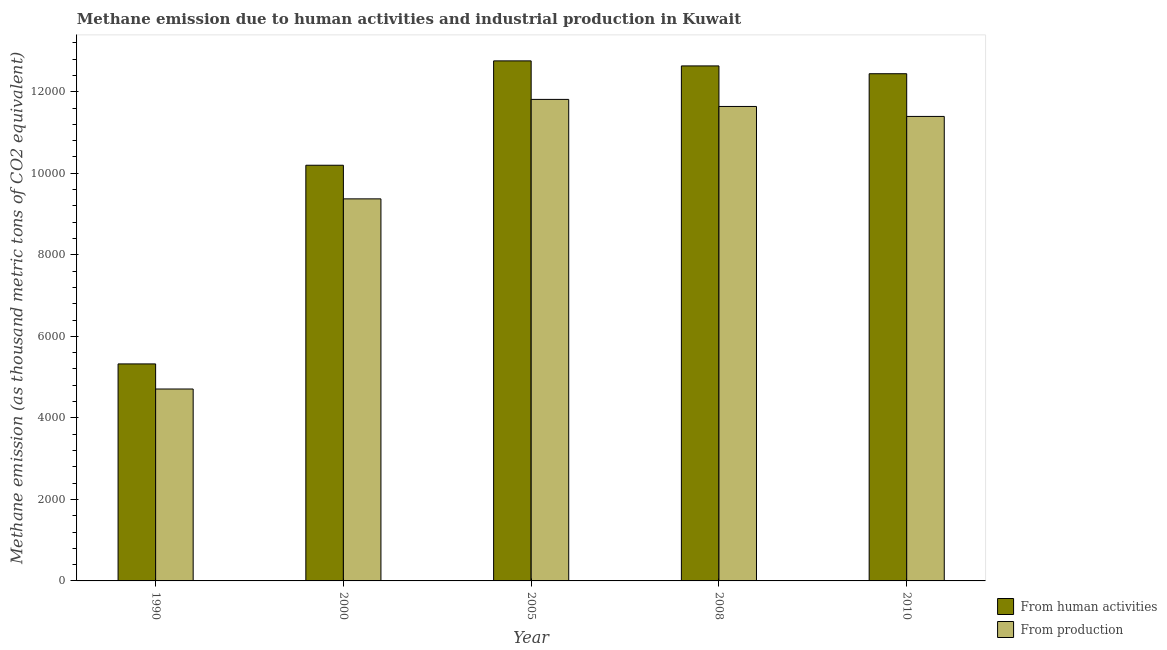How many different coloured bars are there?
Your answer should be very brief. 2. How many groups of bars are there?
Give a very brief answer. 5. Are the number of bars per tick equal to the number of legend labels?
Offer a terse response. Yes. How many bars are there on the 3rd tick from the left?
Provide a short and direct response. 2. What is the amount of emissions generated from industries in 2000?
Offer a very short reply. 9372. Across all years, what is the maximum amount of emissions from human activities?
Offer a terse response. 1.28e+04. Across all years, what is the minimum amount of emissions generated from industries?
Your answer should be compact. 4707.5. What is the total amount of emissions from human activities in the graph?
Make the answer very short. 5.34e+04. What is the difference between the amount of emissions from human activities in 2008 and that in 2010?
Your answer should be very brief. 191.4. What is the difference between the amount of emissions from human activities in 2005 and the amount of emissions generated from industries in 2010?
Make the answer very short. 315.1. What is the average amount of emissions generated from industries per year?
Ensure brevity in your answer.  9784.84. In the year 2005, what is the difference between the amount of emissions generated from industries and amount of emissions from human activities?
Provide a succinct answer. 0. In how many years, is the amount of emissions generated from industries greater than 4800 thousand metric tons?
Your response must be concise. 4. What is the ratio of the amount of emissions from human activities in 2000 to that in 2008?
Offer a very short reply. 0.81. Is the amount of emissions from human activities in 2000 less than that in 2005?
Provide a succinct answer. Yes. What is the difference between the highest and the second highest amount of emissions generated from industries?
Provide a short and direct response. 172.9. What is the difference between the highest and the lowest amount of emissions from human activities?
Make the answer very short. 7433.7. Is the sum of the amount of emissions from human activities in 2005 and 2008 greater than the maximum amount of emissions generated from industries across all years?
Give a very brief answer. Yes. What does the 2nd bar from the left in 1990 represents?
Ensure brevity in your answer.  From production. What does the 1st bar from the right in 2000 represents?
Provide a short and direct response. From production. How many bars are there?
Keep it short and to the point. 10. Are all the bars in the graph horizontal?
Make the answer very short. No. Does the graph contain any zero values?
Give a very brief answer. No. What is the title of the graph?
Your answer should be compact. Methane emission due to human activities and industrial production in Kuwait. Does "Taxes on profits and capital gains" appear as one of the legend labels in the graph?
Your answer should be very brief. No. What is the label or title of the Y-axis?
Keep it short and to the point. Methane emission (as thousand metric tons of CO2 equivalent). What is the Methane emission (as thousand metric tons of CO2 equivalent) of From human activities in 1990?
Make the answer very short. 5323.1. What is the Methane emission (as thousand metric tons of CO2 equivalent) in From production in 1990?
Ensure brevity in your answer.  4707.5. What is the Methane emission (as thousand metric tons of CO2 equivalent) of From human activities in 2000?
Provide a short and direct response. 1.02e+04. What is the Methane emission (as thousand metric tons of CO2 equivalent) of From production in 2000?
Provide a succinct answer. 9372. What is the Methane emission (as thousand metric tons of CO2 equivalent) of From human activities in 2005?
Your answer should be compact. 1.28e+04. What is the Methane emission (as thousand metric tons of CO2 equivalent) of From production in 2005?
Provide a short and direct response. 1.18e+04. What is the Methane emission (as thousand metric tons of CO2 equivalent) in From human activities in 2008?
Ensure brevity in your answer.  1.26e+04. What is the Methane emission (as thousand metric tons of CO2 equivalent) of From production in 2008?
Offer a terse response. 1.16e+04. What is the Methane emission (as thousand metric tons of CO2 equivalent) of From human activities in 2010?
Make the answer very short. 1.24e+04. What is the Methane emission (as thousand metric tons of CO2 equivalent) of From production in 2010?
Your answer should be very brief. 1.14e+04. Across all years, what is the maximum Methane emission (as thousand metric tons of CO2 equivalent) of From human activities?
Your answer should be compact. 1.28e+04. Across all years, what is the maximum Methane emission (as thousand metric tons of CO2 equivalent) in From production?
Offer a very short reply. 1.18e+04. Across all years, what is the minimum Methane emission (as thousand metric tons of CO2 equivalent) in From human activities?
Offer a very short reply. 5323.1. Across all years, what is the minimum Methane emission (as thousand metric tons of CO2 equivalent) in From production?
Give a very brief answer. 4707.5. What is the total Methane emission (as thousand metric tons of CO2 equivalent) of From human activities in the graph?
Your answer should be compact. 5.34e+04. What is the total Methane emission (as thousand metric tons of CO2 equivalent) of From production in the graph?
Keep it short and to the point. 4.89e+04. What is the difference between the Methane emission (as thousand metric tons of CO2 equivalent) in From human activities in 1990 and that in 2000?
Make the answer very short. -4873.7. What is the difference between the Methane emission (as thousand metric tons of CO2 equivalent) of From production in 1990 and that in 2000?
Give a very brief answer. -4664.5. What is the difference between the Methane emission (as thousand metric tons of CO2 equivalent) in From human activities in 1990 and that in 2005?
Ensure brevity in your answer.  -7433.7. What is the difference between the Methane emission (as thousand metric tons of CO2 equivalent) of From production in 1990 and that in 2005?
Provide a short and direct response. -7104.2. What is the difference between the Methane emission (as thousand metric tons of CO2 equivalent) of From human activities in 1990 and that in 2008?
Make the answer very short. -7310. What is the difference between the Methane emission (as thousand metric tons of CO2 equivalent) in From production in 1990 and that in 2008?
Offer a very short reply. -6931.3. What is the difference between the Methane emission (as thousand metric tons of CO2 equivalent) of From human activities in 1990 and that in 2010?
Provide a short and direct response. -7118.6. What is the difference between the Methane emission (as thousand metric tons of CO2 equivalent) in From production in 1990 and that in 2010?
Your answer should be very brief. -6686.7. What is the difference between the Methane emission (as thousand metric tons of CO2 equivalent) of From human activities in 2000 and that in 2005?
Ensure brevity in your answer.  -2560. What is the difference between the Methane emission (as thousand metric tons of CO2 equivalent) in From production in 2000 and that in 2005?
Give a very brief answer. -2439.7. What is the difference between the Methane emission (as thousand metric tons of CO2 equivalent) in From human activities in 2000 and that in 2008?
Your answer should be very brief. -2436.3. What is the difference between the Methane emission (as thousand metric tons of CO2 equivalent) of From production in 2000 and that in 2008?
Ensure brevity in your answer.  -2266.8. What is the difference between the Methane emission (as thousand metric tons of CO2 equivalent) of From human activities in 2000 and that in 2010?
Make the answer very short. -2244.9. What is the difference between the Methane emission (as thousand metric tons of CO2 equivalent) in From production in 2000 and that in 2010?
Keep it short and to the point. -2022.2. What is the difference between the Methane emission (as thousand metric tons of CO2 equivalent) in From human activities in 2005 and that in 2008?
Ensure brevity in your answer.  123.7. What is the difference between the Methane emission (as thousand metric tons of CO2 equivalent) in From production in 2005 and that in 2008?
Keep it short and to the point. 172.9. What is the difference between the Methane emission (as thousand metric tons of CO2 equivalent) of From human activities in 2005 and that in 2010?
Provide a succinct answer. 315.1. What is the difference between the Methane emission (as thousand metric tons of CO2 equivalent) in From production in 2005 and that in 2010?
Your answer should be very brief. 417.5. What is the difference between the Methane emission (as thousand metric tons of CO2 equivalent) of From human activities in 2008 and that in 2010?
Offer a very short reply. 191.4. What is the difference between the Methane emission (as thousand metric tons of CO2 equivalent) in From production in 2008 and that in 2010?
Give a very brief answer. 244.6. What is the difference between the Methane emission (as thousand metric tons of CO2 equivalent) in From human activities in 1990 and the Methane emission (as thousand metric tons of CO2 equivalent) in From production in 2000?
Make the answer very short. -4048.9. What is the difference between the Methane emission (as thousand metric tons of CO2 equivalent) of From human activities in 1990 and the Methane emission (as thousand metric tons of CO2 equivalent) of From production in 2005?
Your response must be concise. -6488.6. What is the difference between the Methane emission (as thousand metric tons of CO2 equivalent) of From human activities in 1990 and the Methane emission (as thousand metric tons of CO2 equivalent) of From production in 2008?
Your answer should be compact. -6315.7. What is the difference between the Methane emission (as thousand metric tons of CO2 equivalent) of From human activities in 1990 and the Methane emission (as thousand metric tons of CO2 equivalent) of From production in 2010?
Ensure brevity in your answer.  -6071.1. What is the difference between the Methane emission (as thousand metric tons of CO2 equivalent) of From human activities in 2000 and the Methane emission (as thousand metric tons of CO2 equivalent) of From production in 2005?
Your answer should be compact. -1614.9. What is the difference between the Methane emission (as thousand metric tons of CO2 equivalent) of From human activities in 2000 and the Methane emission (as thousand metric tons of CO2 equivalent) of From production in 2008?
Your answer should be very brief. -1442. What is the difference between the Methane emission (as thousand metric tons of CO2 equivalent) of From human activities in 2000 and the Methane emission (as thousand metric tons of CO2 equivalent) of From production in 2010?
Offer a very short reply. -1197.4. What is the difference between the Methane emission (as thousand metric tons of CO2 equivalent) of From human activities in 2005 and the Methane emission (as thousand metric tons of CO2 equivalent) of From production in 2008?
Offer a very short reply. 1118. What is the difference between the Methane emission (as thousand metric tons of CO2 equivalent) of From human activities in 2005 and the Methane emission (as thousand metric tons of CO2 equivalent) of From production in 2010?
Your answer should be compact. 1362.6. What is the difference between the Methane emission (as thousand metric tons of CO2 equivalent) in From human activities in 2008 and the Methane emission (as thousand metric tons of CO2 equivalent) in From production in 2010?
Ensure brevity in your answer.  1238.9. What is the average Methane emission (as thousand metric tons of CO2 equivalent) of From human activities per year?
Your answer should be compact. 1.07e+04. What is the average Methane emission (as thousand metric tons of CO2 equivalent) in From production per year?
Provide a succinct answer. 9784.84. In the year 1990, what is the difference between the Methane emission (as thousand metric tons of CO2 equivalent) of From human activities and Methane emission (as thousand metric tons of CO2 equivalent) of From production?
Provide a short and direct response. 615.6. In the year 2000, what is the difference between the Methane emission (as thousand metric tons of CO2 equivalent) in From human activities and Methane emission (as thousand metric tons of CO2 equivalent) in From production?
Keep it short and to the point. 824.8. In the year 2005, what is the difference between the Methane emission (as thousand metric tons of CO2 equivalent) in From human activities and Methane emission (as thousand metric tons of CO2 equivalent) in From production?
Provide a succinct answer. 945.1. In the year 2008, what is the difference between the Methane emission (as thousand metric tons of CO2 equivalent) in From human activities and Methane emission (as thousand metric tons of CO2 equivalent) in From production?
Offer a terse response. 994.3. In the year 2010, what is the difference between the Methane emission (as thousand metric tons of CO2 equivalent) in From human activities and Methane emission (as thousand metric tons of CO2 equivalent) in From production?
Your answer should be very brief. 1047.5. What is the ratio of the Methane emission (as thousand metric tons of CO2 equivalent) of From human activities in 1990 to that in 2000?
Make the answer very short. 0.52. What is the ratio of the Methane emission (as thousand metric tons of CO2 equivalent) of From production in 1990 to that in 2000?
Your answer should be very brief. 0.5. What is the ratio of the Methane emission (as thousand metric tons of CO2 equivalent) in From human activities in 1990 to that in 2005?
Keep it short and to the point. 0.42. What is the ratio of the Methane emission (as thousand metric tons of CO2 equivalent) of From production in 1990 to that in 2005?
Keep it short and to the point. 0.4. What is the ratio of the Methane emission (as thousand metric tons of CO2 equivalent) in From human activities in 1990 to that in 2008?
Ensure brevity in your answer.  0.42. What is the ratio of the Methane emission (as thousand metric tons of CO2 equivalent) of From production in 1990 to that in 2008?
Offer a very short reply. 0.4. What is the ratio of the Methane emission (as thousand metric tons of CO2 equivalent) of From human activities in 1990 to that in 2010?
Offer a terse response. 0.43. What is the ratio of the Methane emission (as thousand metric tons of CO2 equivalent) in From production in 1990 to that in 2010?
Your answer should be compact. 0.41. What is the ratio of the Methane emission (as thousand metric tons of CO2 equivalent) of From human activities in 2000 to that in 2005?
Your answer should be compact. 0.8. What is the ratio of the Methane emission (as thousand metric tons of CO2 equivalent) in From production in 2000 to that in 2005?
Ensure brevity in your answer.  0.79. What is the ratio of the Methane emission (as thousand metric tons of CO2 equivalent) of From human activities in 2000 to that in 2008?
Your answer should be very brief. 0.81. What is the ratio of the Methane emission (as thousand metric tons of CO2 equivalent) of From production in 2000 to that in 2008?
Provide a short and direct response. 0.81. What is the ratio of the Methane emission (as thousand metric tons of CO2 equivalent) in From human activities in 2000 to that in 2010?
Provide a short and direct response. 0.82. What is the ratio of the Methane emission (as thousand metric tons of CO2 equivalent) of From production in 2000 to that in 2010?
Keep it short and to the point. 0.82. What is the ratio of the Methane emission (as thousand metric tons of CO2 equivalent) of From human activities in 2005 to that in 2008?
Offer a terse response. 1.01. What is the ratio of the Methane emission (as thousand metric tons of CO2 equivalent) in From production in 2005 to that in 2008?
Make the answer very short. 1.01. What is the ratio of the Methane emission (as thousand metric tons of CO2 equivalent) of From human activities in 2005 to that in 2010?
Your answer should be compact. 1.03. What is the ratio of the Methane emission (as thousand metric tons of CO2 equivalent) in From production in 2005 to that in 2010?
Your answer should be compact. 1.04. What is the ratio of the Methane emission (as thousand metric tons of CO2 equivalent) of From human activities in 2008 to that in 2010?
Provide a short and direct response. 1.02. What is the ratio of the Methane emission (as thousand metric tons of CO2 equivalent) in From production in 2008 to that in 2010?
Your answer should be compact. 1.02. What is the difference between the highest and the second highest Methane emission (as thousand metric tons of CO2 equivalent) of From human activities?
Keep it short and to the point. 123.7. What is the difference between the highest and the second highest Methane emission (as thousand metric tons of CO2 equivalent) in From production?
Offer a very short reply. 172.9. What is the difference between the highest and the lowest Methane emission (as thousand metric tons of CO2 equivalent) in From human activities?
Provide a short and direct response. 7433.7. What is the difference between the highest and the lowest Methane emission (as thousand metric tons of CO2 equivalent) of From production?
Provide a short and direct response. 7104.2. 